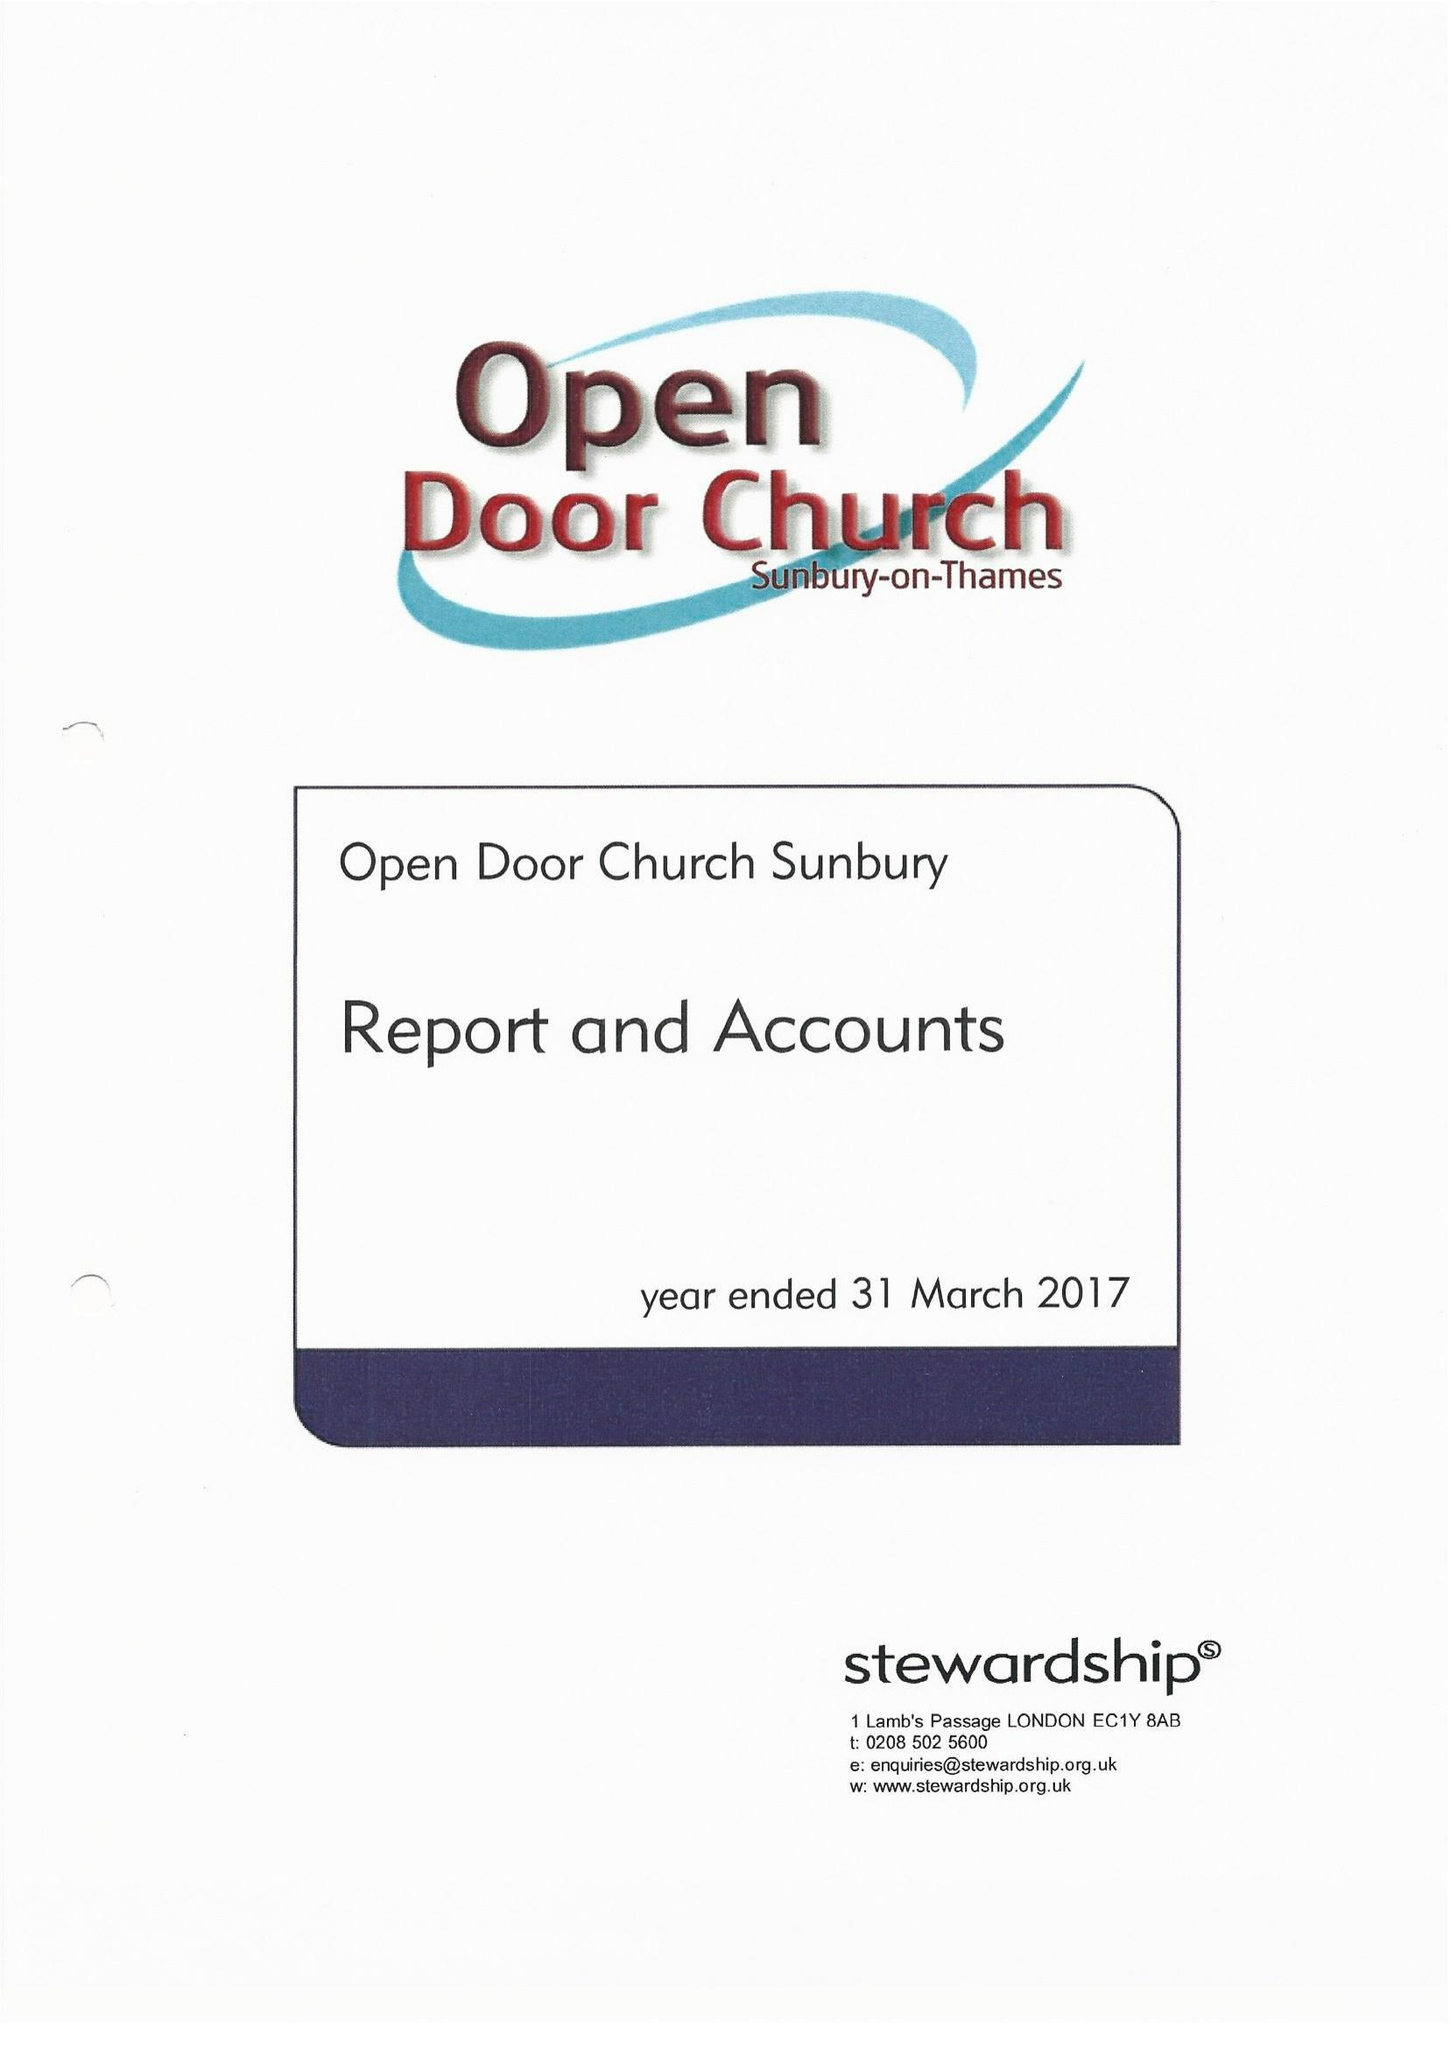What is the value for the report_date?
Answer the question using a single word or phrase. 2017-03-31 